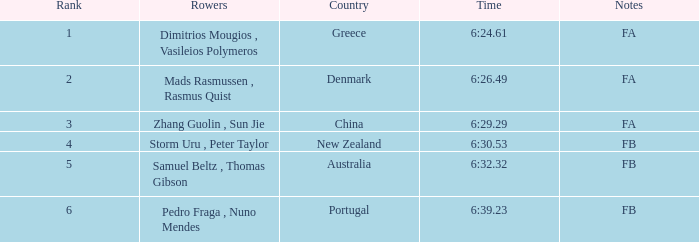What is the standing of the time 6:3 1.0. 